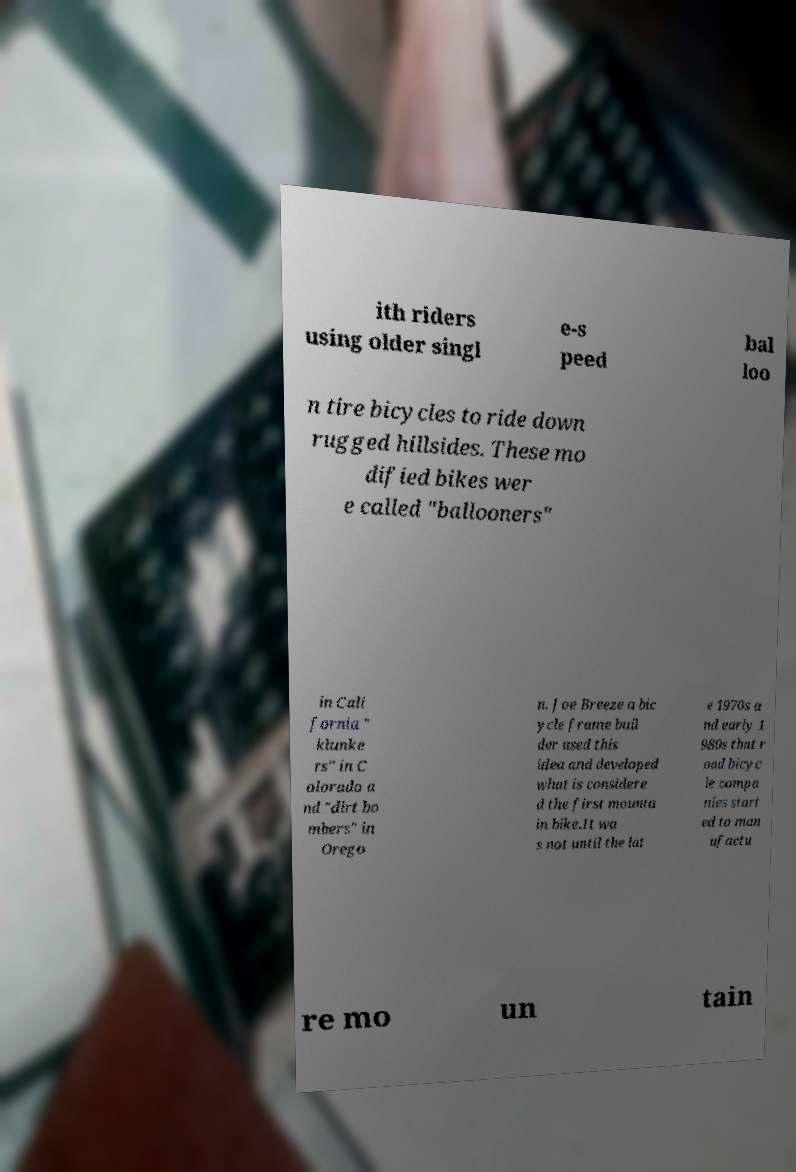Could you extract and type out the text from this image? ith riders using older singl e-s peed bal loo n tire bicycles to ride down rugged hillsides. These mo dified bikes wer e called "ballooners" in Cali fornia " klunke rs" in C olorado a nd "dirt bo mbers" in Orego n. Joe Breeze a bic ycle frame buil der used this idea and developed what is considere d the first mounta in bike.It wa s not until the lat e 1970s a nd early 1 980s that r oad bicyc le compa nies start ed to man ufactu re mo un tain 